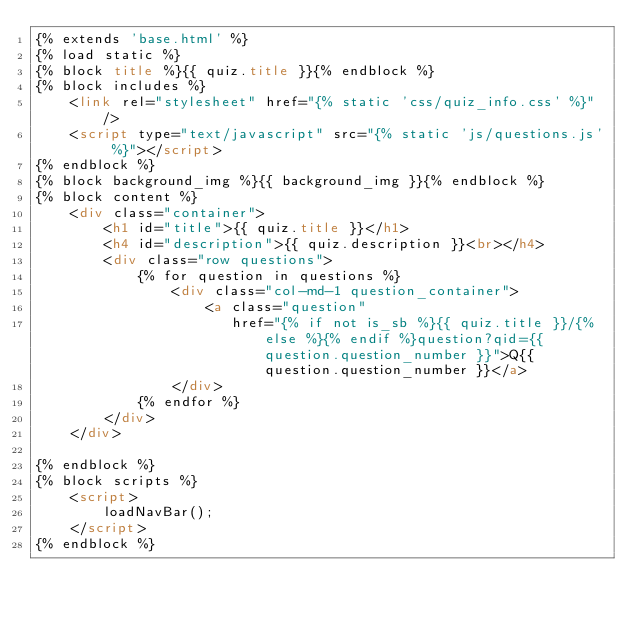Convert code to text. <code><loc_0><loc_0><loc_500><loc_500><_HTML_>{% extends 'base.html' %}
{% load static %}
{% block title %}{{ quiz.title }}{% endblock %}
{% block includes %}
    <link rel="stylesheet" href="{% static 'css/quiz_info.css' %}"/>
    <script type="text/javascript" src="{% static 'js/questions.js' %}"></script>
{% endblock %}
{% block background_img %}{{ background_img }}{% endblock %}
{% block content %}
    <div class="container">
        <h1 id="title">{{ quiz.title }}</h1>
        <h4 id="description">{{ quiz.description }}<br></h4>
        <div class="row questions">
            {% for question in questions %}
                <div class="col-md-1 question_container">
                    <a class="question"
                       href="{% if not is_sb %}{{ quiz.title }}/{% else %}{% endif %}question?qid={{ question.question_number }}">Q{{ question.question_number }}</a>
                </div>
            {% endfor %}
        </div>
    </div>

{% endblock %}
{% block scripts %}
    <script>
        loadNavBar();
    </script>
{% endblock %}</code> 